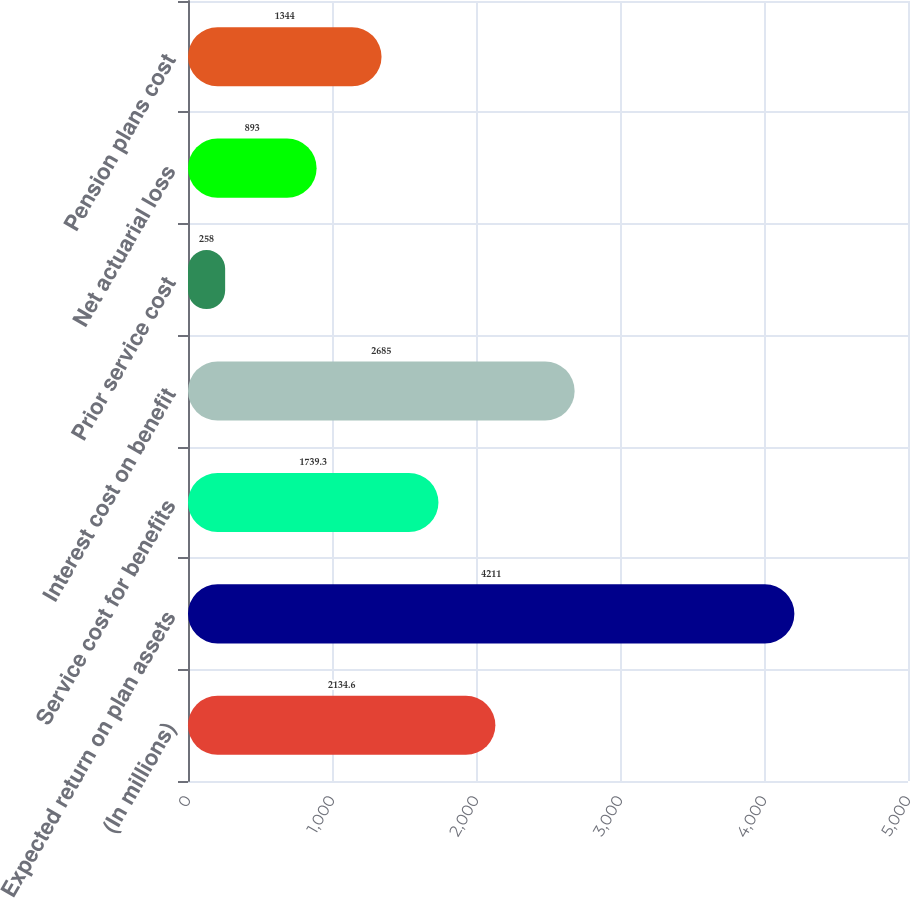Convert chart. <chart><loc_0><loc_0><loc_500><loc_500><bar_chart><fcel>(In millions)<fcel>Expected return on plan assets<fcel>Service cost for benefits<fcel>Interest cost on benefit<fcel>Prior service cost<fcel>Net actuarial loss<fcel>Pension plans cost<nl><fcel>2134.6<fcel>4211<fcel>1739.3<fcel>2685<fcel>258<fcel>893<fcel>1344<nl></chart> 